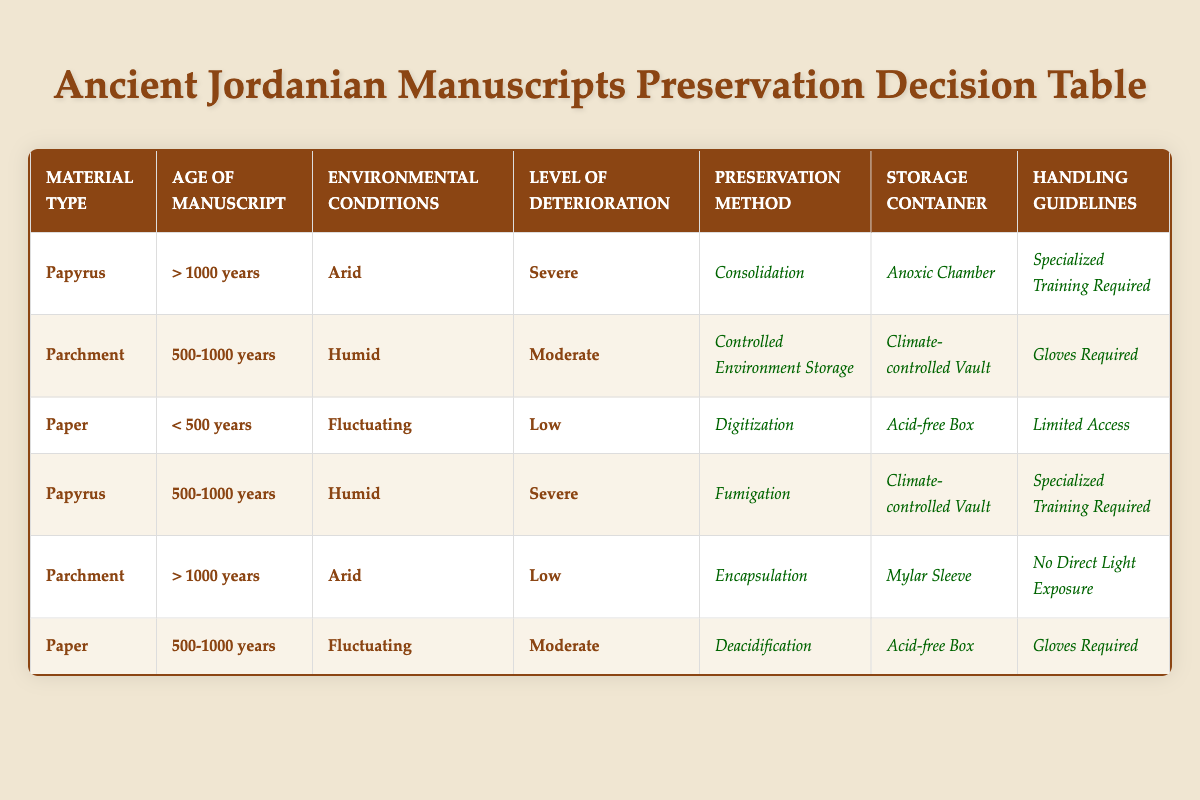What is the preservation method for papyrus manuscripts over 1000 years old and in severe condition? The table shows that for papyrus manuscripts older than 1000 years with severe deterioration, the preservation method is consolidation.
Answer: Consolidation Which storage container is recommended for parchment manuscripts that are 500-1000 years old in humid conditions with moderate deterioration? According to the table, the recommended storage container for parchment manuscripts that are 500-1000 years old, in humid conditions with moderate deterioration, is a climate-controlled vault.
Answer: Climate-controlled vault Are digitization and an acid-free box recommended for paper manuscripts younger than 500 years old with low deterioration in fluctuating conditions? Yes, the table specifies that the preservation method for paper manuscripts under 500 years old with low deterioration in fluctuating conditions is digitization, and the storage container is an acid-free box.
Answer: Yes How many preservation methods are indicated for paper manuscripts with moderate deterioration? There are two entries in the table for paper manuscripts with moderate deterioration: one for ages 500-1000 years with deacidification and acid-free box, and another for 500-1000 years, which is already counted, so the total is 1 preservation method indicated for this specific condition.
Answer: 1 If a parchment manuscript is over 1000 years old and in low deterioration found in an arid climate, what handling guideline should be followed? The handling guideline for a parchment manuscript older than 1000 years and in low deterioration located in arid conditions, according to the table, is no direct light exposure.
Answer: No direct light exposure What are the handling guidelines for papyrus manuscripts that are 500-1000 years old and in a humid environment with severe deterioration? The table states that for papyrus manuscripts aged 500-1000 years, in humid conditions with severe deterioration, the handling guideline requires specialized training.
Answer: Specialized training required Is encapsulation an appropriate storage method for parchment manuscripts older than 1000 years in an arid environment with low deterioration? Yes, the table indicates that encapsulation is the preservation method for such parchment manuscripts.
Answer: Yes What is the relationship between the age of manuscripts and the recommended preservation methods in cases of severe deterioration? The table shows different preservation methods based on age and deterioration levels. For severe deterioration, older manuscripts (over 1000 years) use consolidation, while those aged 500-1000 years use fumigation. Therefore, older age tends to require more intensive preservation methods.
Answer: Preservation methods become more intensive with age in severe cases 